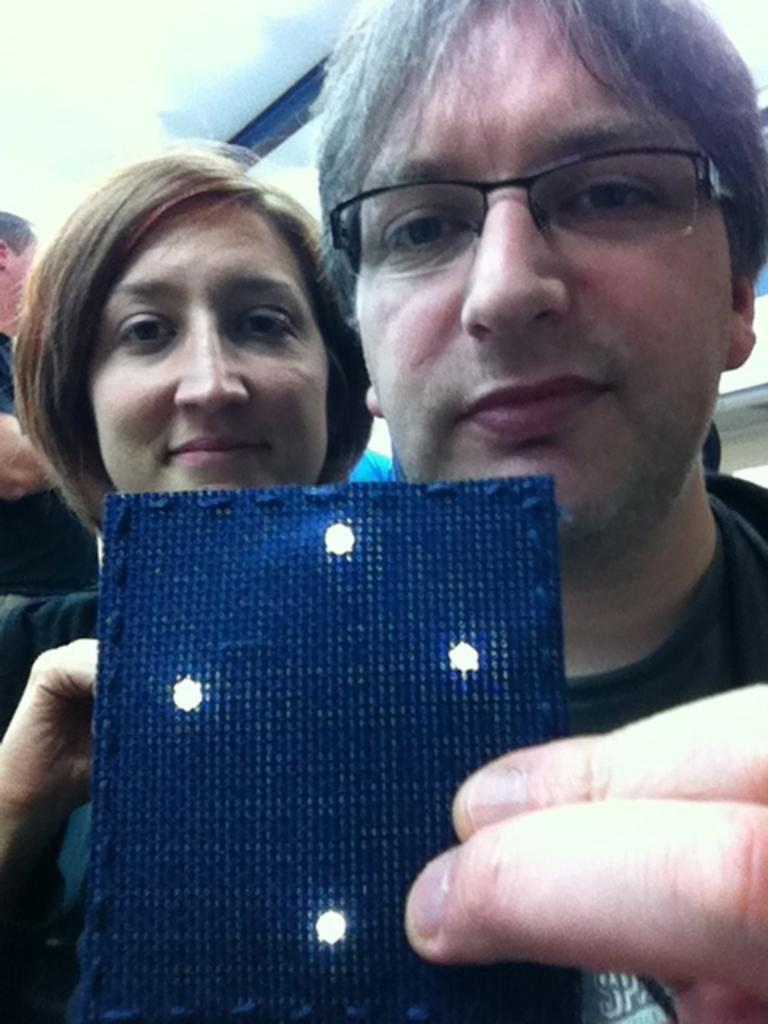What is the blue object that the two persons are holding in the image? The blue object is not specified in the facts provided. Where is the person sitting in the image? The person is sitting on a chair, as mentioned in the transcript. What is the person reading in the image? The person is reading a book, as mentioned in the transcript. What is on the table next to the chair in the image? There is a cup of coffee on the table, as mentioned in the transcript. What is the cat doing in the image? The cat is sitting on a windowsill and looking out the window, as mentioned in the transcript. How many people are in the group in the image? There is no specific number mentioned in the facts provided. What are the people doing in the image? The people are standing in a circle and holding hands, as mentioned in the transcript. What is the dog doing in the image? The dog is lying on a rug and sleeping, as mentioned in the transcript. How many hands does the cat have in the image? Cats do not have hands; they have paws. What type of egg is being used to sort items in the image? There is no mention of eggs or sorting in any of the provided facts or transcripts. 